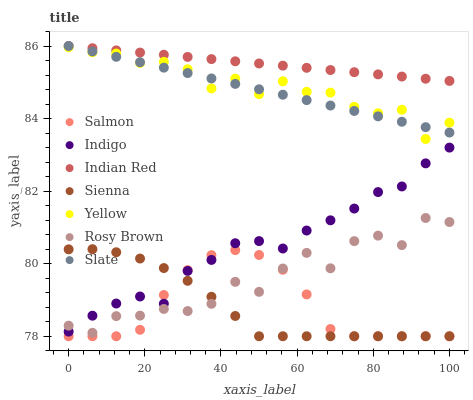Does Sienna have the minimum area under the curve?
Answer yes or no. Yes. Does Indian Red have the maximum area under the curve?
Answer yes or no. Yes. Does Slate have the minimum area under the curve?
Answer yes or no. No. Does Slate have the maximum area under the curve?
Answer yes or no. No. Is Slate the smoothest?
Answer yes or no. Yes. Is Rosy Brown the roughest?
Answer yes or no. Yes. Is Rosy Brown the smoothest?
Answer yes or no. No. Is Slate the roughest?
Answer yes or no. No. Does Salmon have the lowest value?
Answer yes or no. Yes. Does Slate have the lowest value?
Answer yes or no. No. Does Indian Red have the highest value?
Answer yes or no. Yes. Does Rosy Brown have the highest value?
Answer yes or no. No. Is Yellow less than Indian Red?
Answer yes or no. Yes. Is Yellow greater than Rosy Brown?
Answer yes or no. Yes. Does Sienna intersect Salmon?
Answer yes or no. Yes. Is Sienna less than Salmon?
Answer yes or no. No. Is Sienna greater than Salmon?
Answer yes or no. No. Does Yellow intersect Indian Red?
Answer yes or no. No. 